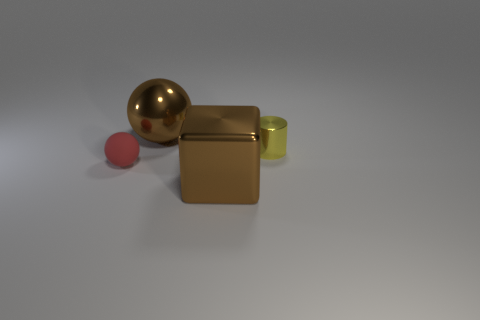Add 3 red matte balls. How many objects exist? 7 Subtract all cylinders. How many objects are left? 3 Subtract 0 green cylinders. How many objects are left? 4 Subtract all big objects. Subtract all large yellow rubber balls. How many objects are left? 2 Add 4 brown metal things. How many brown metal things are left? 6 Add 3 small yellow cylinders. How many small yellow cylinders exist? 4 